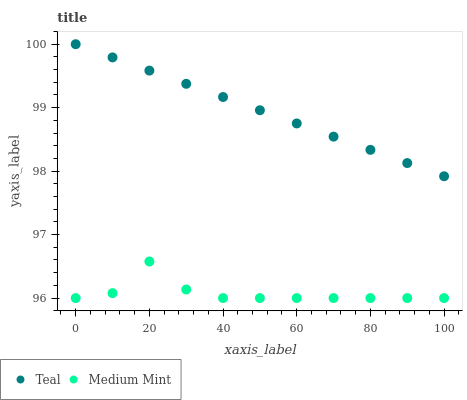Does Medium Mint have the minimum area under the curve?
Answer yes or no. Yes. Does Teal have the maximum area under the curve?
Answer yes or no. Yes. Does Teal have the minimum area under the curve?
Answer yes or no. No. Is Teal the smoothest?
Answer yes or no. Yes. Is Medium Mint the roughest?
Answer yes or no. Yes. Is Teal the roughest?
Answer yes or no. No. Does Medium Mint have the lowest value?
Answer yes or no. Yes. Does Teal have the lowest value?
Answer yes or no. No. Does Teal have the highest value?
Answer yes or no. Yes. Is Medium Mint less than Teal?
Answer yes or no. Yes. Is Teal greater than Medium Mint?
Answer yes or no. Yes. Does Medium Mint intersect Teal?
Answer yes or no. No. 